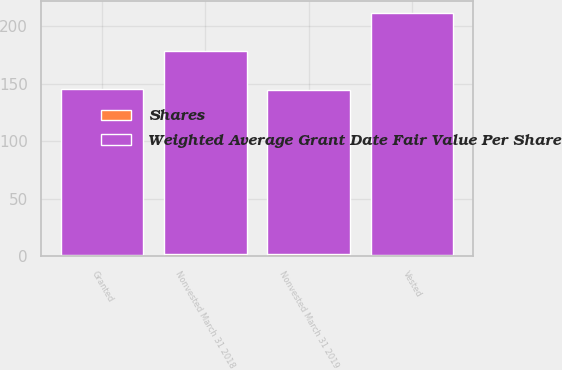Convert chart to OTSL. <chart><loc_0><loc_0><loc_500><loc_500><stacked_bar_chart><ecel><fcel>Nonvested March 31 2018<fcel>Granted<fcel>Vested<fcel>Nonvested March 31 2019<nl><fcel>Shares<fcel>2<fcel>1<fcel>1<fcel>2<nl><fcel>Weighted Average Grant Date Fair Value Per Share<fcel>176.74<fcel>143.94<fcel>210.3<fcel>142.77<nl></chart> 